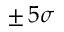Convert formula to latex. <formula><loc_0><loc_0><loc_500><loc_500>\pm \, 5 \sigma</formula> 